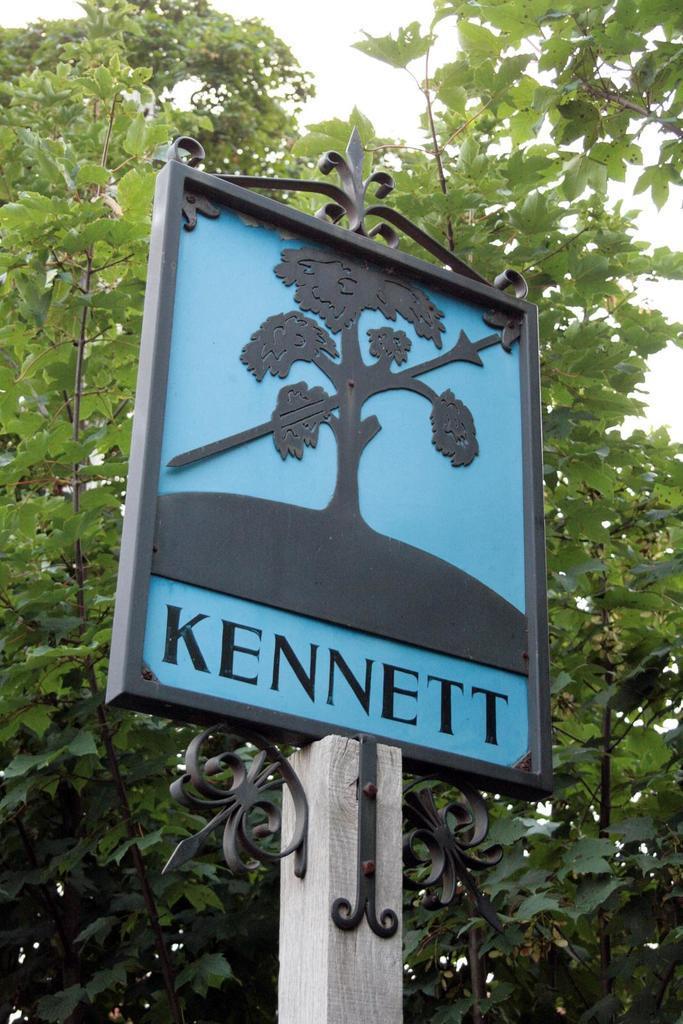Please provide a concise description of this image. In this image in the front there is pole and on the top of the pole there is a board with some text and image on it. In the background there are trees. 